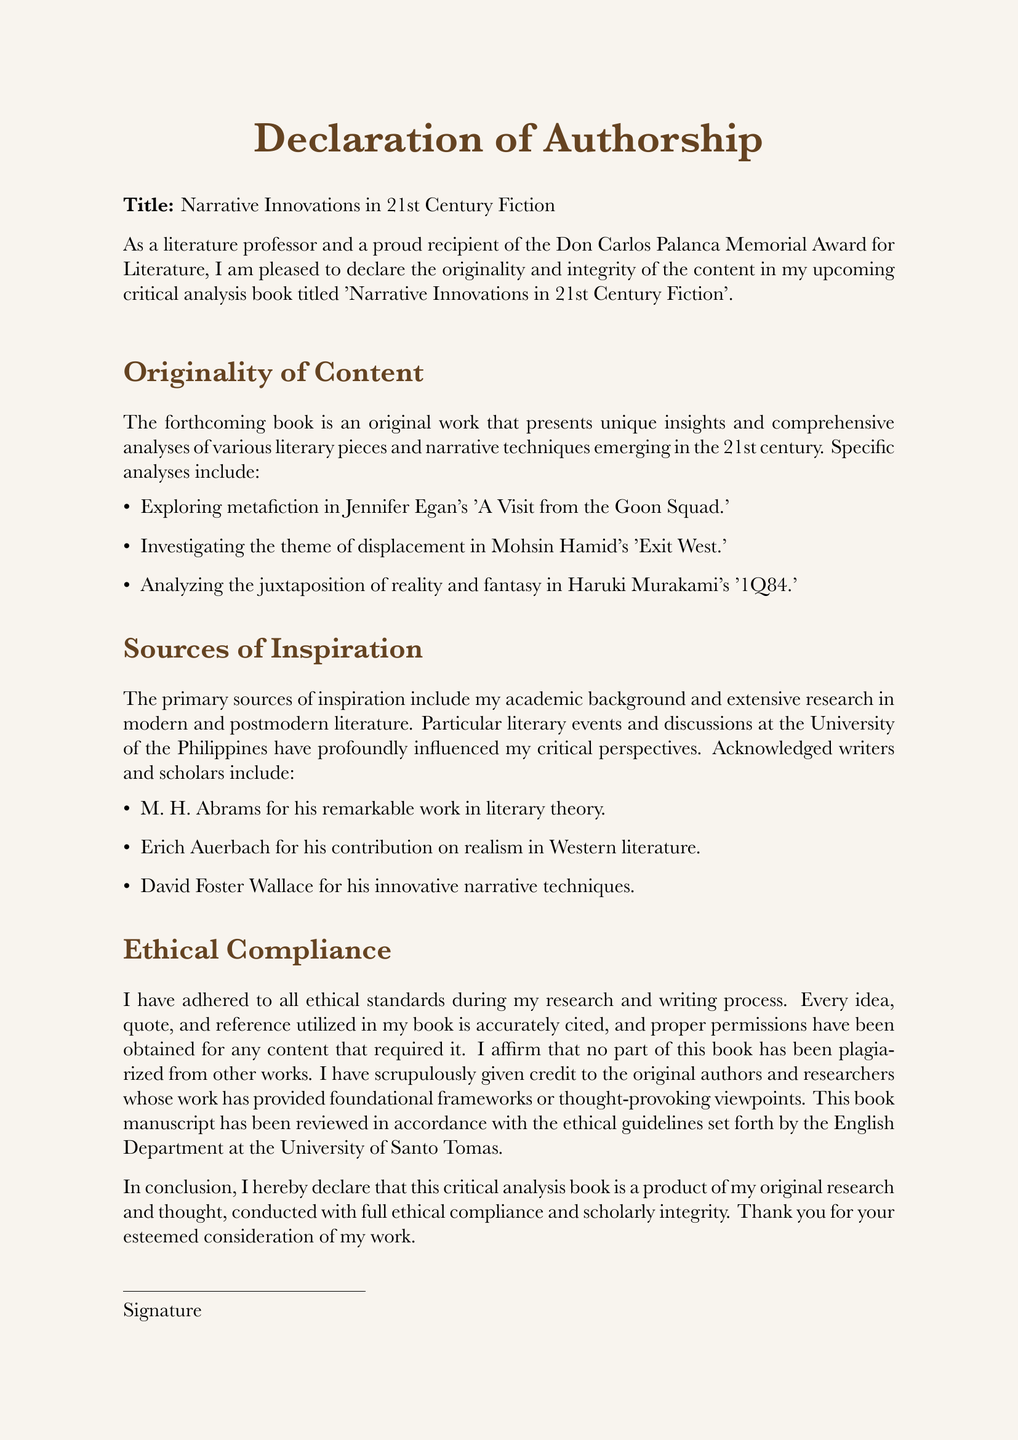What is the title of the upcoming book? The title is mentioned in the declaration and highlights the focus of the work.
Answer: Narrative Innovations in 21st Century Fiction Who are two of the authors cited as sources of inspiration? The document lists notable writers that influenced the author's insights and perspectives.
Answer: M. H. Abrams, Erich Auerbach How many literary pieces are specifically analyzed in the book? The declaration outlines three specific literary analyses included in the content.
Answer: Three What is the author's title and recognition mentioned? The author's credentials and achievements are stated, establishing their expertise in literature.
Answer: Literature professor and recipient of the Don Carlos Palanca Memorial Award for Literature What ethical guideline has the manuscript adhered to? The document references adherence to the ethical standards established by an academic institution.
Answer: English Department at the University of Santo Tomas Which narrative techniques are examined in Jennifer Egan's work? The declaration presents the focus of the analysis regarding a specific literary technique in Egan's work.
Answer: Metafiction What is affirmed regarding the originality of content? The document emphasizes the integrity of the book's content and its basis on original research.
Answer: Original work What genre does the book focus on? The declaration pertains to a specific genre within literature, highlighting its academic focus.
Answer: Fiction 